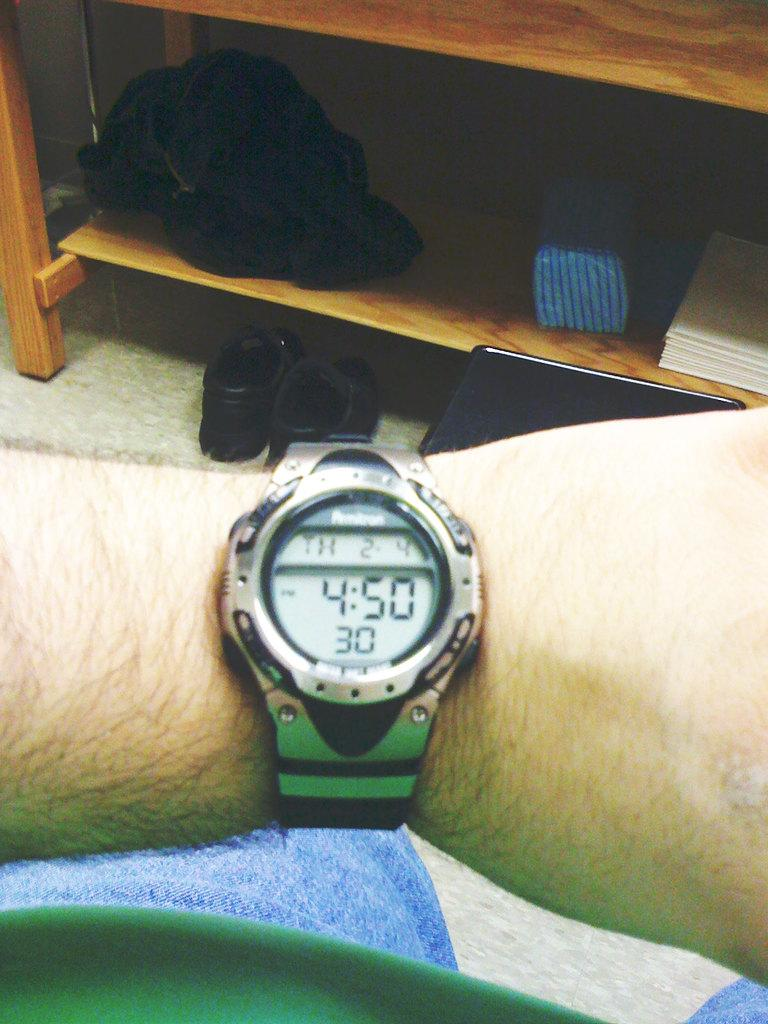Provide a one-sentence caption for the provided image. A wrist watch that reads 4:50 P.M., Th 2-4. 